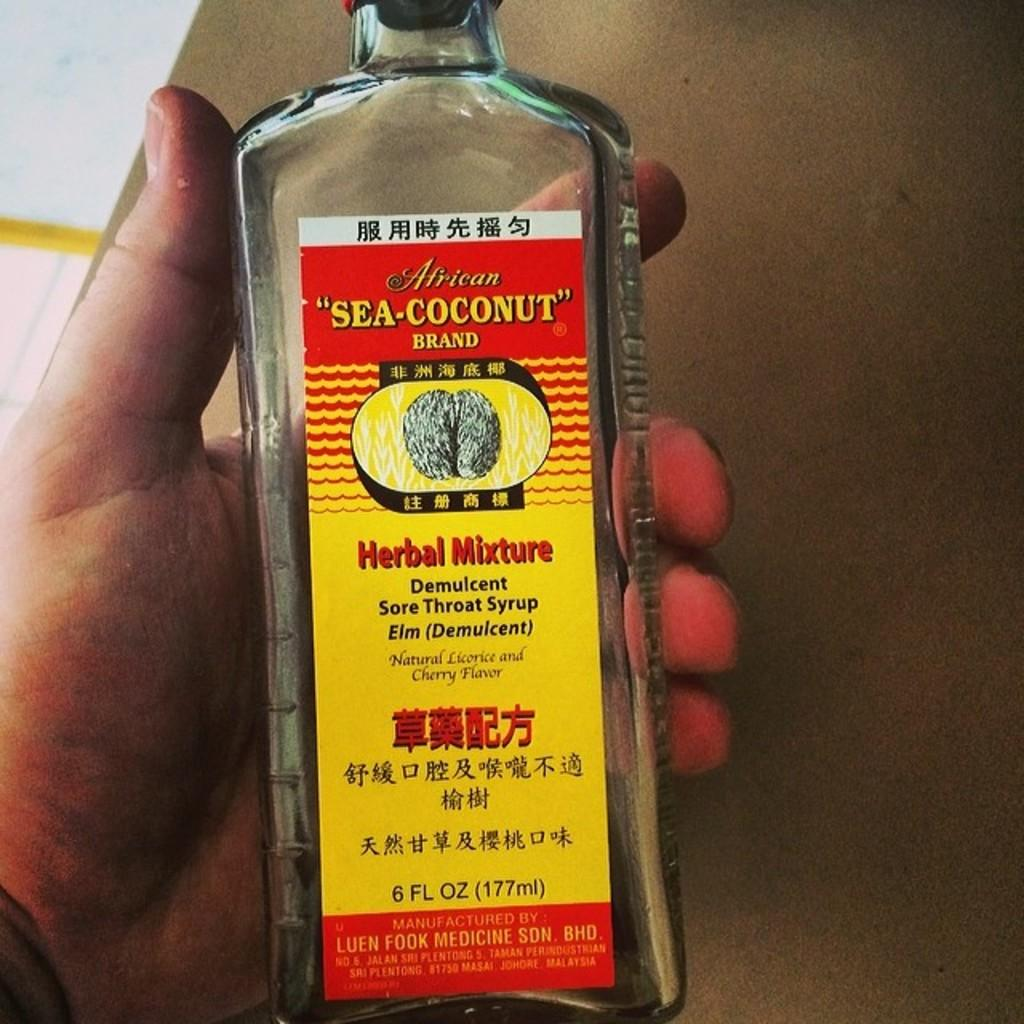<image>
Describe the image concisely. A hand holds a bottle of Sea-Coconut Brand Herbal Mixture, Sore Throat Syrup. 